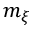<formula> <loc_0><loc_0><loc_500><loc_500>m _ { \xi }</formula> 